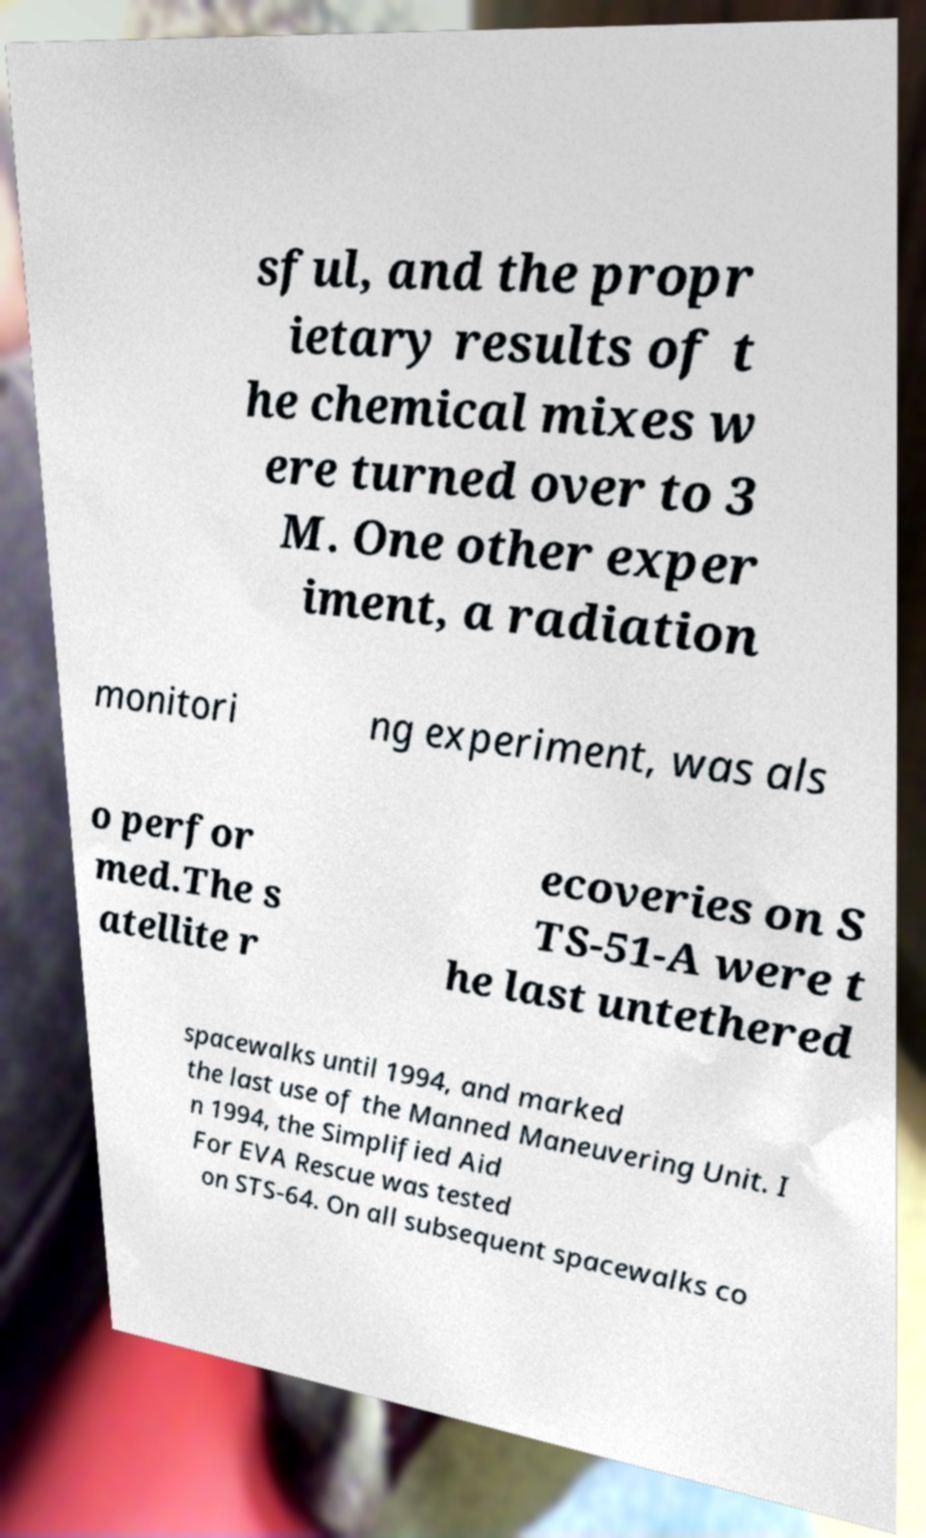Could you extract and type out the text from this image? sful, and the propr ietary results of t he chemical mixes w ere turned over to 3 M. One other exper iment, a radiation monitori ng experiment, was als o perfor med.The s atellite r ecoveries on S TS-51-A were t he last untethered spacewalks until 1994, and marked the last use of the Manned Maneuvering Unit. I n 1994, the Simplified Aid For EVA Rescue was tested on STS-64. On all subsequent spacewalks co 